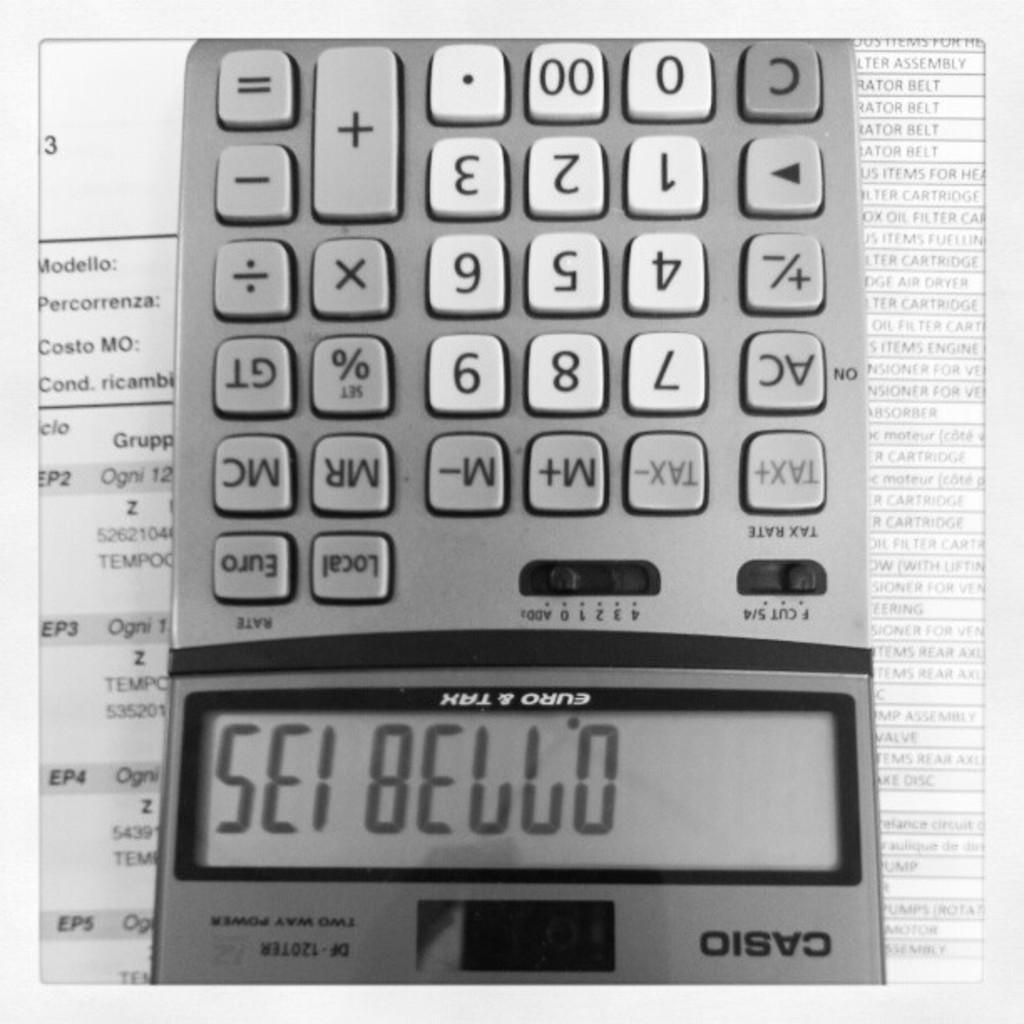<image>
Write a terse but informative summary of the picture. A Casio calculator has output displayed on its screen. 